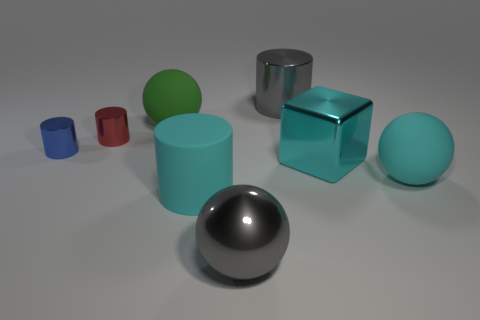Subtract 1 cylinders. How many cylinders are left? 3 Add 1 big cyan metallic blocks. How many objects exist? 9 Subtract all blocks. How many objects are left? 7 Add 8 big cyan balls. How many big cyan balls are left? 9 Add 5 large red cylinders. How many large red cylinders exist? 5 Subtract 0 blue blocks. How many objects are left? 8 Subtract all large green matte cylinders. Subtract all large green spheres. How many objects are left? 7 